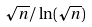Convert formula to latex. <formula><loc_0><loc_0><loc_500><loc_500>\sqrt { n } / \ln ( \sqrt { n } )</formula> 